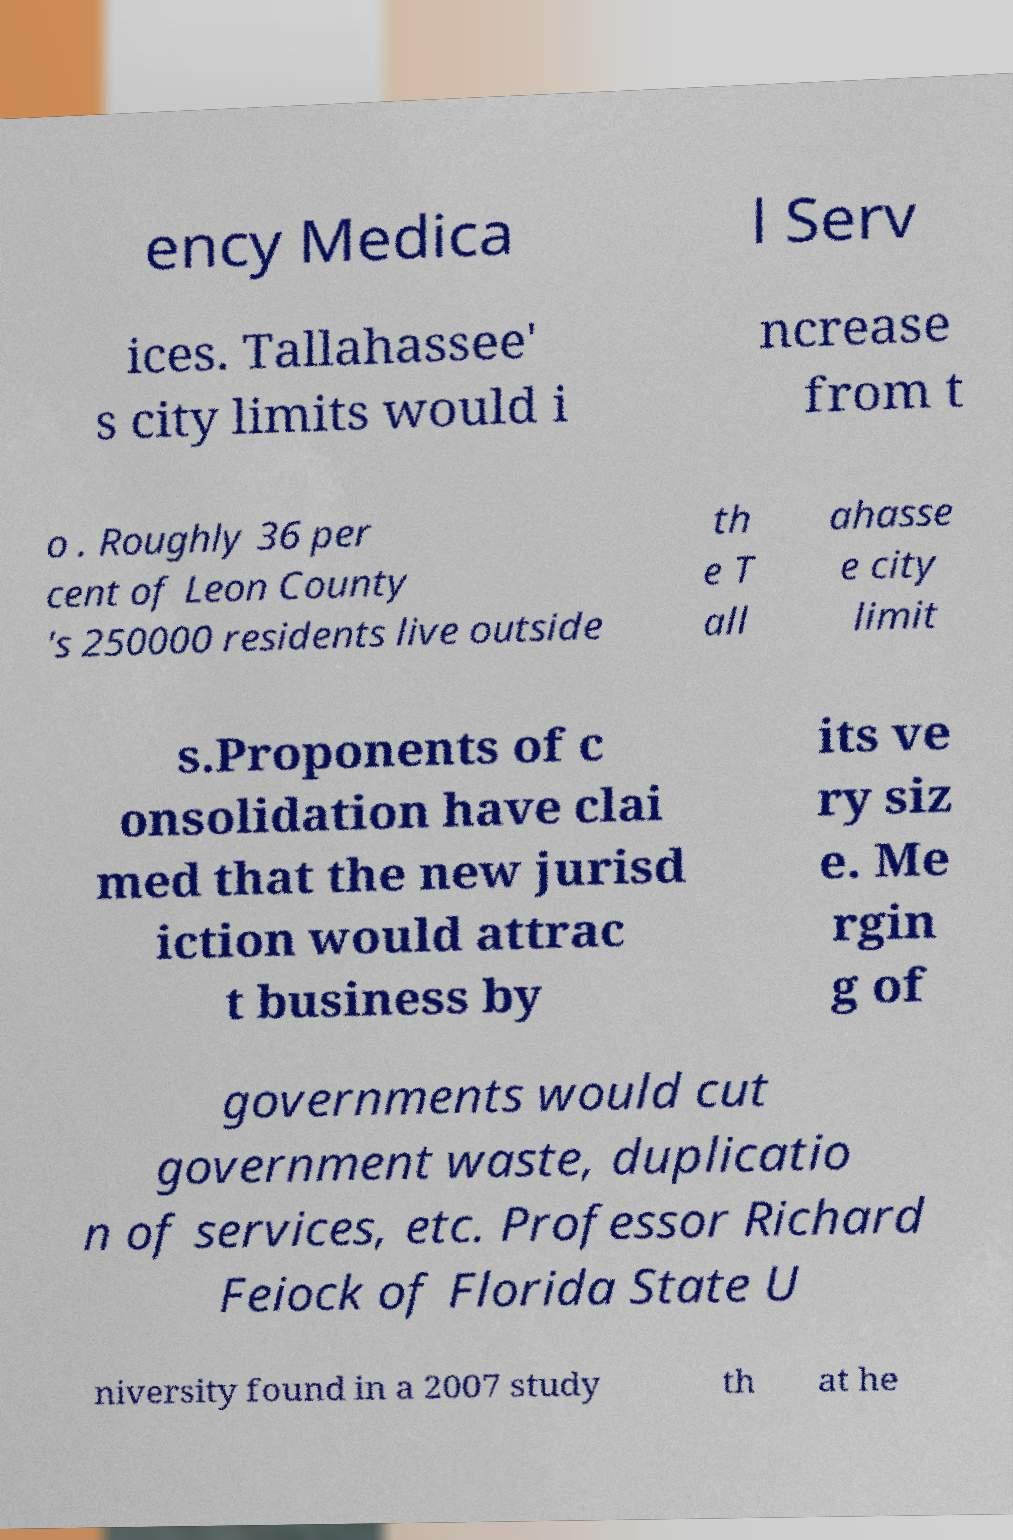What messages or text are displayed in this image? I need them in a readable, typed format. ency Medica l Serv ices. Tallahassee' s city limits would i ncrease from t o . Roughly 36 per cent of Leon County 's 250000 residents live outside th e T all ahasse e city limit s.Proponents of c onsolidation have clai med that the new jurisd iction would attrac t business by its ve ry siz e. Me rgin g of governments would cut government waste, duplicatio n of services, etc. Professor Richard Feiock of Florida State U niversity found in a 2007 study th at he 